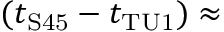<formula> <loc_0><loc_0><loc_500><loc_500>( t _ { S 4 5 } - t _ { T U 1 } ) \approx</formula> 